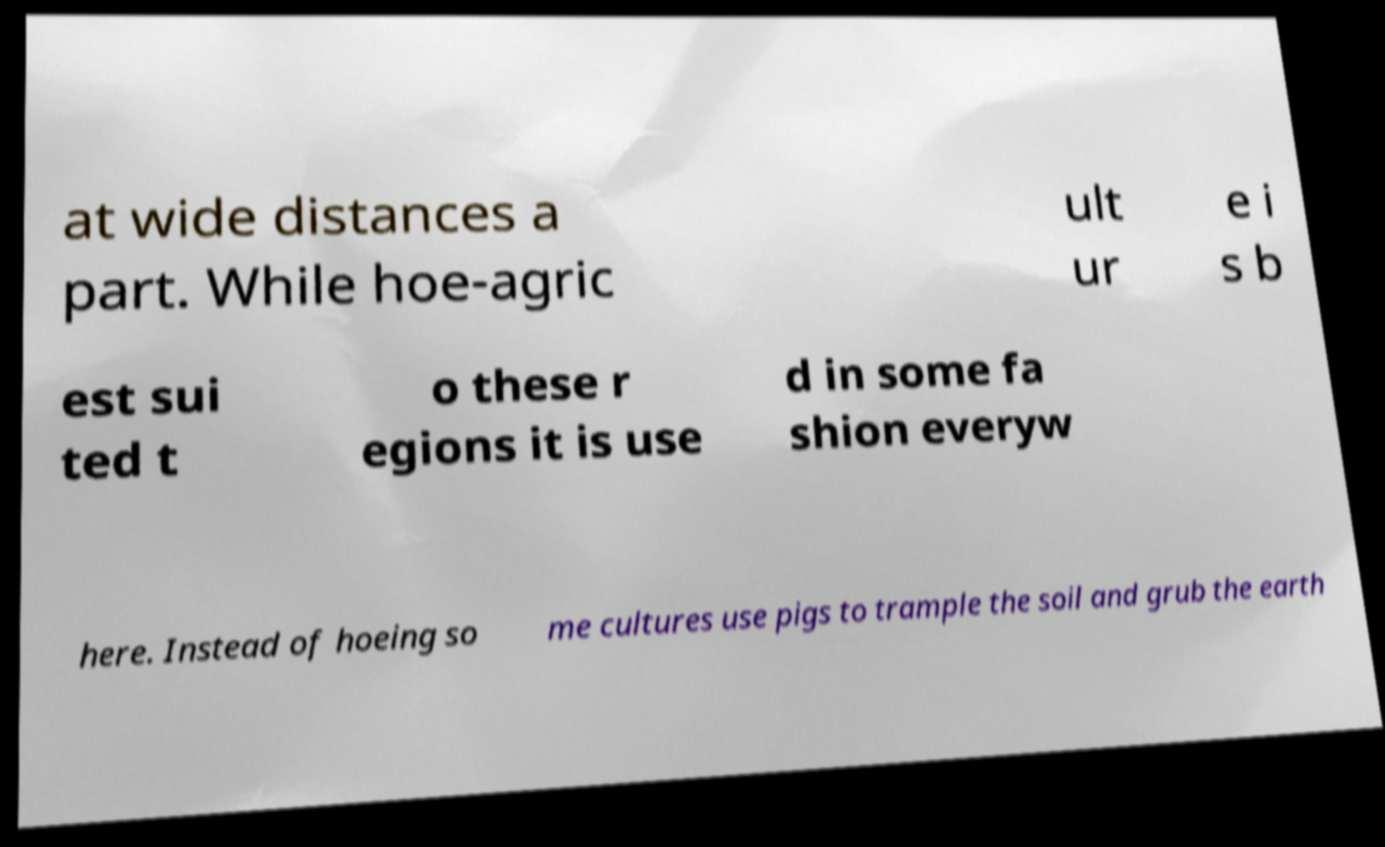For documentation purposes, I need the text within this image transcribed. Could you provide that? at wide distances a part. While hoe-agric ult ur e i s b est sui ted t o these r egions it is use d in some fa shion everyw here. Instead of hoeing so me cultures use pigs to trample the soil and grub the earth 